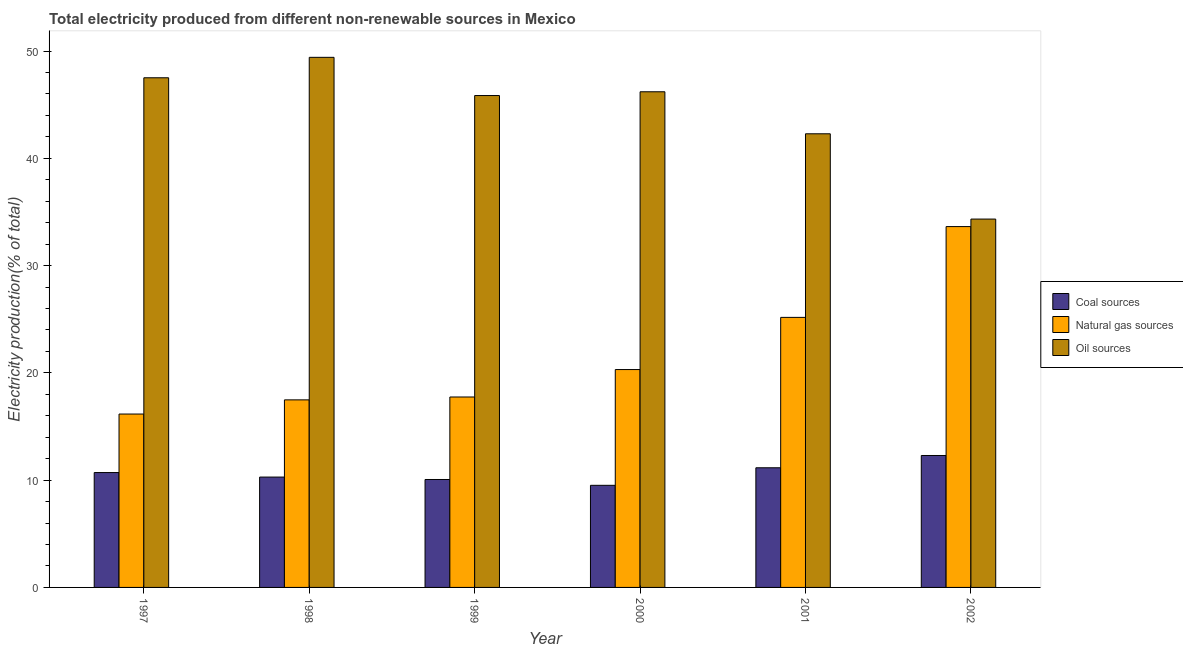Are the number of bars on each tick of the X-axis equal?
Your response must be concise. Yes. How many bars are there on the 6th tick from the left?
Provide a succinct answer. 3. How many bars are there on the 5th tick from the right?
Ensure brevity in your answer.  3. What is the label of the 5th group of bars from the left?
Ensure brevity in your answer.  2001. What is the percentage of electricity produced by oil sources in 2001?
Your answer should be very brief. 42.28. Across all years, what is the maximum percentage of electricity produced by oil sources?
Offer a very short reply. 49.41. Across all years, what is the minimum percentage of electricity produced by coal?
Keep it short and to the point. 9.52. In which year was the percentage of electricity produced by natural gas maximum?
Provide a succinct answer. 2002. In which year was the percentage of electricity produced by coal minimum?
Provide a succinct answer. 2000. What is the total percentage of electricity produced by natural gas in the graph?
Your response must be concise. 130.51. What is the difference between the percentage of electricity produced by natural gas in 1997 and that in 2000?
Your response must be concise. -4.15. What is the difference between the percentage of electricity produced by oil sources in 2000 and the percentage of electricity produced by coal in 2002?
Make the answer very short. 11.87. What is the average percentage of electricity produced by oil sources per year?
Your response must be concise. 44.26. What is the ratio of the percentage of electricity produced by natural gas in 1997 to that in 2001?
Your answer should be very brief. 0.64. Is the percentage of electricity produced by natural gas in 1997 less than that in 2001?
Offer a very short reply. Yes. What is the difference between the highest and the second highest percentage of electricity produced by oil sources?
Your response must be concise. 1.91. What is the difference between the highest and the lowest percentage of electricity produced by oil sources?
Your response must be concise. 15.08. Is the sum of the percentage of electricity produced by oil sources in 2000 and 2001 greater than the maximum percentage of electricity produced by natural gas across all years?
Keep it short and to the point. Yes. What does the 2nd bar from the left in 2002 represents?
Your answer should be very brief. Natural gas sources. What does the 1st bar from the right in 1998 represents?
Make the answer very short. Oil sources. Are all the bars in the graph horizontal?
Provide a succinct answer. No. How many years are there in the graph?
Provide a short and direct response. 6. Does the graph contain any zero values?
Make the answer very short. No. Where does the legend appear in the graph?
Ensure brevity in your answer.  Center right. How many legend labels are there?
Your response must be concise. 3. What is the title of the graph?
Make the answer very short. Total electricity produced from different non-renewable sources in Mexico. What is the label or title of the Y-axis?
Provide a short and direct response. Electricity production(% of total). What is the Electricity production(% of total) in Coal sources in 1997?
Offer a very short reply. 10.71. What is the Electricity production(% of total) in Natural gas sources in 1997?
Ensure brevity in your answer.  16.16. What is the Electricity production(% of total) of Oil sources in 1997?
Your answer should be compact. 47.5. What is the Electricity production(% of total) in Coal sources in 1998?
Offer a terse response. 10.29. What is the Electricity production(% of total) in Natural gas sources in 1998?
Give a very brief answer. 17.48. What is the Electricity production(% of total) in Oil sources in 1998?
Your answer should be compact. 49.41. What is the Electricity production(% of total) of Coal sources in 1999?
Keep it short and to the point. 10.06. What is the Electricity production(% of total) of Natural gas sources in 1999?
Keep it short and to the point. 17.75. What is the Electricity production(% of total) of Oil sources in 1999?
Your answer should be very brief. 45.85. What is the Electricity production(% of total) of Coal sources in 2000?
Provide a succinct answer. 9.52. What is the Electricity production(% of total) in Natural gas sources in 2000?
Give a very brief answer. 20.31. What is the Electricity production(% of total) of Oil sources in 2000?
Keep it short and to the point. 46.2. What is the Electricity production(% of total) in Coal sources in 2001?
Your answer should be compact. 11.15. What is the Electricity production(% of total) in Natural gas sources in 2001?
Your answer should be compact. 25.17. What is the Electricity production(% of total) of Oil sources in 2001?
Make the answer very short. 42.28. What is the Electricity production(% of total) in Coal sources in 2002?
Ensure brevity in your answer.  12.3. What is the Electricity production(% of total) in Natural gas sources in 2002?
Make the answer very short. 33.63. What is the Electricity production(% of total) of Oil sources in 2002?
Offer a very short reply. 34.33. Across all years, what is the maximum Electricity production(% of total) of Coal sources?
Offer a very short reply. 12.3. Across all years, what is the maximum Electricity production(% of total) in Natural gas sources?
Your answer should be very brief. 33.63. Across all years, what is the maximum Electricity production(% of total) of Oil sources?
Your answer should be very brief. 49.41. Across all years, what is the minimum Electricity production(% of total) in Coal sources?
Give a very brief answer. 9.52. Across all years, what is the minimum Electricity production(% of total) of Natural gas sources?
Provide a succinct answer. 16.16. Across all years, what is the minimum Electricity production(% of total) of Oil sources?
Provide a short and direct response. 34.33. What is the total Electricity production(% of total) of Coal sources in the graph?
Make the answer very short. 64.02. What is the total Electricity production(% of total) in Natural gas sources in the graph?
Provide a succinct answer. 130.51. What is the total Electricity production(% of total) of Oil sources in the graph?
Offer a very short reply. 265.58. What is the difference between the Electricity production(% of total) of Coal sources in 1997 and that in 1998?
Provide a short and direct response. 0.42. What is the difference between the Electricity production(% of total) of Natural gas sources in 1997 and that in 1998?
Your answer should be compact. -1.32. What is the difference between the Electricity production(% of total) in Oil sources in 1997 and that in 1998?
Your answer should be very brief. -1.91. What is the difference between the Electricity production(% of total) in Coal sources in 1997 and that in 1999?
Ensure brevity in your answer.  0.65. What is the difference between the Electricity production(% of total) of Natural gas sources in 1997 and that in 1999?
Ensure brevity in your answer.  -1.59. What is the difference between the Electricity production(% of total) of Oil sources in 1997 and that in 1999?
Offer a terse response. 1.66. What is the difference between the Electricity production(% of total) in Coal sources in 1997 and that in 2000?
Ensure brevity in your answer.  1.19. What is the difference between the Electricity production(% of total) of Natural gas sources in 1997 and that in 2000?
Ensure brevity in your answer.  -4.15. What is the difference between the Electricity production(% of total) of Oil sources in 1997 and that in 2000?
Your response must be concise. 1.31. What is the difference between the Electricity production(% of total) of Coal sources in 1997 and that in 2001?
Make the answer very short. -0.45. What is the difference between the Electricity production(% of total) of Natural gas sources in 1997 and that in 2001?
Your answer should be compact. -9.01. What is the difference between the Electricity production(% of total) of Oil sources in 1997 and that in 2001?
Provide a short and direct response. 5.22. What is the difference between the Electricity production(% of total) in Coal sources in 1997 and that in 2002?
Offer a terse response. -1.59. What is the difference between the Electricity production(% of total) in Natural gas sources in 1997 and that in 2002?
Provide a short and direct response. -17.47. What is the difference between the Electricity production(% of total) in Oil sources in 1997 and that in 2002?
Your answer should be very brief. 13.17. What is the difference between the Electricity production(% of total) of Coal sources in 1998 and that in 1999?
Offer a very short reply. 0.23. What is the difference between the Electricity production(% of total) of Natural gas sources in 1998 and that in 1999?
Make the answer very short. -0.27. What is the difference between the Electricity production(% of total) of Oil sources in 1998 and that in 1999?
Make the answer very short. 3.56. What is the difference between the Electricity production(% of total) of Coal sources in 1998 and that in 2000?
Ensure brevity in your answer.  0.77. What is the difference between the Electricity production(% of total) in Natural gas sources in 1998 and that in 2000?
Your answer should be compact. -2.83. What is the difference between the Electricity production(% of total) in Oil sources in 1998 and that in 2000?
Ensure brevity in your answer.  3.21. What is the difference between the Electricity production(% of total) in Coal sources in 1998 and that in 2001?
Your answer should be very brief. -0.87. What is the difference between the Electricity production(% of total) in Natural gas sources in 1998 and that in 2001?
Ensure brevity in your answer.  -7.69. What is the difference between the Electricity production(% of total) of Oil sources in 1998 and that in 2001?
Offer a terse response. 7.13. What is the difference between the Electricity production(% of total) of Coal sources in 1998 and that in 2002?
Your response must be concise. -2.01. What is the difference between the Electricity production(% of total) of Natural gas sources in 1998 and that in 2002?
Offer a very short reply. -16.15. What is the difference between the Electricity production(% of total) in Oil sources in 1998 and that in 2002?
Make the answer very short. 15.08. What is the difference between the Electricity production(% of total) in Coal sources in 1999 and that in 2000?
Your answer should be compact. 0.54. What is the difference between the Electricity production(% of total) of Natural gas sources in 1999 and that in 2000?
Provide a succinct answer. -2.56. What is the difference between the Electricity production(% of total) of Oil sources in 1999 and that in 2000?
Make the answer very short. -0.35. What is the difference between the Electricity production(% of total) in Coal sources in 1999 and that in 2001?
Provide a succinct answer. -1.09. What is the difference between the Electricity production(% of total) of Natural gas sources in 1999 and that in 2001?
Your response must be concise. -7.42. What is the difference between the Electricity production(% of total) of Oil sources in 1999 and that in 2001?
Provide a succinct answer. 3.57. What is the difference between the Electricity production(% of total) in Coal sources in 1999 and that in 2002?
Your response must be concise. -2.24. What is the difference between the Electricity production(% of total) of Natural gas sources in 1999 and that in 2002?
Offer a very short reply. -15.88. What is the difference between the Electricity production(% of total) in Oil sources in 1999 and that in 2002?
Your response must be concise. 11.51. What is the difference between the Electricity production(% of total) of Coal sources in 2000 and that in 2001?
Keep it short and to the point. -1.64. What is the difference between the Electricity production(% of total) of Natural gas sources in 2000 and that in 2001?
Ensure brevity in your answer.  -4.86. What is the difference between the Electricity production(% of total) of Oil sources in 2000 and that in 2001?
Give a very brief answer. 3.92. What is the difference between the Electricity production(% of total) of Coal sources in 2000 and that in 2002?
Make the answer very short. -2.78. What is the difference between the Electricity production(% of total) in Natural gas sources in 2000 and that in 2002?
Provide a short and direct response. -13.33. What is the difference between the Electricity production(% of total) of Oil sources in 2000 and that in 2002?
Your answer should be very brief. 11.87. What is the difference between the Electricity production(% of total) in Coal sources in 2001 and that in 2002?
Make the answer very short. -1.14. What is the difference between the Electricity production(% of total) of Natural gas sources in 2001 and that in 2002?
Your response must be concise. -8.46. What is the difference between the Electricity production(% of total) of Oil sources in 2001 and that in 2002?
Your response must be concise. 7.95. What is the difference between the Electricity production(% of total) of Coal sources in 1997 and the Electricity production(% of total) of Natural gas sources in 1998?
Your answer should be compact. -6.78. What is the difference between the Electricity production(% of total) in Coal sources in 1997 and the Electricity production(% of total) in Oil sources in 1998?
Give a very brief answer. -38.7. What is the difference between the Electricity production(% of total) in Natural gas sources in 1997 and the Electricity production(% of total) in Oil sources in 1998?
Offer a very short reply. -33.25. What is the difference between the Electricity production(% of total) in Coal sources in 1997 and the Electricity production(% of total) in Natural gas sources in 1999?
Keep it short and to the point. -7.04. What is the difference between the Electricity production(% of total) of Coal sources in 1997 and the Electricity production(% of total) of Oil sources in 1999?
Offer a terse response. -35.14. What is the difference between the Electricity production(% of total) of Natural gas sources in 1997 and the Electricity production(% of total) of Oil sources in 1999?
Provide a short and direct response. -29.69. What is the difference between the Electricity production(% of total) in Coal sources in 1997 and the Electricity production(% of total) in Natural gas sources in 2000?
Ensure brevity in your answer.  -9.6. What is the difference between the Electricity production(% of total) in Coal sources in 1997 and the Electricity production(% of total) in Oil sources in 2000?
Your response must be concise. -35.49. What is the difference between the Electricity production(% of total) in Natural gas sources in 1997 and the Electricity production(% of total) in Oil sources in 2000?
Your answer should be very brief. -30.04. What is the difference between the Electricity production(% of total) in Coal sources in 1997 and the Electricity production(% of total) in Natural gas sources in 2001?
Provide a short and direct response. -14.46. What is the difference between the Electricity production(% of total) in Coal sources in 1997 and the Electricity production(% of total) in Oil sources in 2001?
Give a very brief answer. -31.58. What is the difference between the Electricity production(% of total) in Natural gas sources in 1997 and the Electricity production(% of total) in Oil sources in 2001?
Offer a terse response. -26.12. What is the difference between the Electricity production(% of total) in Coal sources in 1997 and the Electricity production(% of total) in Natural gas sources in 2002?
Ensure brevity in your answer.  -22.93. What is the difference between the Electricity production(% of total) of Coal sources in 1997 and the Electricity production(% of total) of Oil sources in 2002?
Offer a terse response. -23.63. What is the difference between the Electricity production(% of total) of Natural gas sources in 1997 and the Electricity production(% of total) of Oil sources in 2002?
Your response must be concise. -18.17. What is the difference between the Electricity production(% of total) of Coal sources in 1998 and the Electricity production(% of total) of Natural gas sources in 1999?
Provide a short and direct response. -7.46. What is the difference between the Electricity production(% of total) of Coal sources in 1998 and the Electricity production(% of total) of Oil sources in 1999?
Keep it short and to the point. -35.56. What is the difference between the Electricity production(% of total) of Natural gas sources in 1998 and the Electricity production(% of total) of Oil sources in 1999?
Give a very brief answer. -28.37. What is the difference between the Electricity production(% of total) in Coal sources in 1998 and the Electricity production(% of total) in Natural gas sources in 2000?
Your response must be concise. -10.02. What is the difference between the Electricity production(% of total) in Coal sources in 1998 and the Electricity production(% of total) in Oil sources in 2000?
Ensure brevity in your answer.  -35.91. What is the difference between the Electricity production(% of total) in Natural gas sources in 1998 and the Electricity production(% of total) in Oil sources in 2000?
Provide a succinct answer. -28.72. What is the difference between the Electricity production(% of total) in Coal sources in 1998 and the Electricity production(% of total) in Natural gas sources in 2001?
Ensure brevity in your answer.  -14.88. What is the difference between the Electricity production(% of total) in Coal sources in 1998 and the Electricity production(% of total) in Oil sources in 2001?
Offer a very short reply. -32. What is the difference between the Electricity production(% of total) in Natural gas sources in 1998 and the Electricity production(% of total) in Oil sources in 2001?
Your answer should be compact. -24.8. What is the difference between the Electricity production(% of total) of Coal sources in 1998 and the Electricity production(% of total) of Natural gas sources in 2002?
Your answer should be very brief. -23.35. What is the difference between the Electricity production(% of total) of Coal sources in 1998 and the Electricity production(% of total) of Oil sources in 2002?
Ensure brevity in your answer.  -24.05. What is the difference between the Electricity production(% of total) in Natural gas sources in 1998 and the Electricity production(% of total) in Oil sources in 2002?
Offer a very short reply. -16.85. What is the difference between the Electricity production(% of total) of Coal sources in 1999 and the Electricity production(% of total) of Natural gas sources in 2000?
Your response must be concise. -10.25. What is the difference between the Electricity production(% of total) in Coal sources in 1999 and the Electricity production(% of total) in Oil sources in 2000?
Your response must be concise. -36.14. What is the difference between the Electricity production(% of total) in Natural gas sources in 1999 and the Electricity production(% of total) in Oil sources in 2000?
Give a very brief answer. -28.45. What is the difference between the Electricity production(% of total) of Coal sources in 1999 and the Electricity production(% of total) of Natural gas sources in 2001?
Provide a short and direct response. -15.11. What is the difference between the Electricity production(% of total) of Coal sources in 1999 and the Electricity production(% of total) of Oil sources in 2001?
Offer a very short reply. -32.22. What is the difference between the Electricity production(% of total) in Natural gas sources in 1999 and the Electricity production(% of total) in Oil sources in 2001?
Provide a succinct answer. -24.53. What is the difference between the Electricity production(% of total) in Coal sources in 1999 and the Electricity production(% of total) in Natural gas sources in 2002?
Your response must be concise. -23.57. What is the difference between the Electricity production(% of total) in Coal sources in 1999 and the Electricity production(% of total) in Oil sources in 2002?
Keep it short and to the point. -24.27. What is the difference between the Electricity production(% of total) in Natural gas sources in 1999 and the Electricity production(% of total) in Oil sources in 2002?
Your answer should be very brief. -16.58. What is the difference between the Electricity production(% of total) of Coal sources in 2000 and the Electricity production(% of total) of Natural gas sources in 2001?
Give a very brief answer. -15.65. What is the difference between the Electricity production(% of total) of Coal sources in 2000 and the Electricity production(% of total) of Oil sources in 2001?
Offer a terse response. -32.77. What is the difference between the Electricity production(% of total) of Natural gas sources in 2000 and the Electricity production(% of total) of Oil sources in 2001?
Give a very brief answer. -21.98. What is the difference between the Electricity production(% of total) in Coal sources in 2000 and the Electricity production(% of total) in Natural gas sources in 2002?
Your response must be concise. -24.12. What is the difference between the Electricity production(% of total) of Coal sources in 2000 and the Electricity production(% of total) of Oil sources in 2002?
Your response must be concise. -24.82. What is the difference between the Electricity production(% of total) in Natural gas sources in 2000 and the Electricity production(% of total) in Oil sources in 2002?
Provide a short and direct response. -14.03. What is the difference between the Electricity production(% of total) of Coal sources in 2001 and the Electricity production(% of total) of Natural gas sources in 2002?
Offer a very short reply. -22.48. What is the difference between the Electricity production(% of total) of Coal sources in 2001 and the Electricity production(% of total) of Oil sources in 2002?
Provide a short and direct response. -23.18. What is the difference between the Electricity production(% of total) of Natural gas sources in 2001 and the Electricity production(% of total) of Oil sources in 2002?
Offer a terse response. -9.16. What is the average Electricity production(% of total) in Coal sources per year?
Provide a short and direct response. 10.67. What is the average Electricity production(% of total) of Natural gas sources per year?
Provide a succinct answer. 21.75. What is the average Electricity production(% of total) in Oil sources per year?
Keep it short and to the point. 44.26. In the year 1997, what is the difference between the Electricity production(% of total) in Coal sources and Electricity production(% of total) in Natural gas sources?
Give a very brief answer. -5.45. In the year 1997, what is the difference between the Electricity production(% of total) of Coal sources and Electricity production(% of total) of Oil sources?
Your answer should be compact. -36.8. In the year 1997, what is the difference between the Electricity production(% of total) in Natural gas sources and Electricity production(% of total) in Oil sources?
Offer a very short reply. -31.34. In the year 1998, what is the difference between the Electricity production(% of total) in Coal sources and Electricity production(% of total) in Natural gas sources?
Provide a succinct answer. -7.19. In the year 1998, what is the difference between the Electricity production(% of total) of Coal sources and Electricity production(% of total) of Oil sources?
Keep it short and to the point. -39.12. In the year 1998, what is the difference between the Electricity production(% of total) of Natural gas sources and Electricity production(% of total) of Oil sources?
Give a very brief answer. -31.93. In the year 1999, what is the difference between the Electricity production(% of total) of Coal sources and Electricity production(% of total) of Natural gas sources?
Offer a very short reply. -7.69. In the year 1999, what is the difference between the Electricity production(% of total) in Coal sources and Electricity production(% of total) in Oil sources?
Provide a succinct answer. -35.79. In the year 1999, what is the difference between the Electricity production(% of total) of Natural gas sources and Electricity production(% of total) of Oil sources?
Your answer should be compact. -28.1. In the year 2000, what is the difference between the Electricity production(% of total) in Coal sources and Electricity production(% of total) in Natural gas sources?
Offer a very short reply. -10.79. In the year 2000, what is the difference between the Electricity production(% of total) of Coal sources and Electricity production(% of total) of Oil sources?
Your answer should be very brief. -36.68. In the year 2000, what is the difference between the Electricity production(% of total) in Natural gas sources and Electricity production(% of total) in Oil sources?
Keep it short and to the point. -25.89. In the year 2001, what is the difference between the Electricity production(% of total) in Coal sources and Electricity production(% of total) in Natural gas sources?
Provide a short and direct response. -14.02. In the year 2001, what is the difference between the Electricity production(% of total) in Coal sources and Electricity production(% of total) in Oil sources?
Keep it short and to the point. -31.13. In the year 2001, what is the difference between the Electricity production(% of total) of Natural gas sources and Electricity production(% of total) of Oil sources?
Keep it short and to the point. -17.11. In the year 2002, what is the difference between the Electricity production(% of total) in Coal sources and Electricity production(% of total) in Natural gas sources?
Give a very brief answer. -21.34. In the year 2002, what is the difference between the Electricity production(% of total) of Coal sources and Electricity production(% of total) of Oil sources?
Ensure brevity in your answer.  -22.04. In the year 2002, what is the difference between the Electricity production(% of total) of Natural gas sources and Electricity production(% of total) of Oil sources?
Provide a short and direct response. -0.7. What is the ratio of the Electricity production(% of total) of Coal sources in 1997 to that in 1998?
Your answer should be compact. 1.04. What is the ratio of the Electricity production(% of total) of Natural gas sources in 1997 to that in 1998?
Your response must be concise. 0.92. What is the ratio of the Electricity production(% of total) in Oil sources in 1997 to that in 1998?
Provide a succinct answer. 0.96. What is the ratio of the Electricity production(% of total) of Coal sources in 1997 to that in 1999?
Keep it short and to the point. 1.06. What is the ratio of the Electricity production(% of total) in Natural gas sources in 1997 to that in 1999?
Provide a short and direct response. 0.91. What is the ratio of the Electricity production(% of total) in Oil sources in 1997 to that in 1999?
Ensure brevity in your answer.  1.04. What is the ratio of the Electricity production(% of total) in Coal sources in 1997 to that in 2000?
Offer a very short reply. 1.12. What is the ratio of the Electricity production(% of total) in Natural gas sources in 1997 to that in 2000?
Offer a terse response. 0.8. What is the ratio of the Electricity production(% of total) of Oil sources in 1997 to that in 2000?
Make the answer very short. 1.03. What is the ratio of the Electricity production(% of total) of Coal sources in 1997 to that in 2001?
Provide a succinct answer. 0.96. What is the ratio of the Electricity production(% of total) in Natural gas sources in 1997 to that in 2001?
Make the answer very short. 0.64. What is the ratio of the Electricity production(% of total) of Oil sources in 1997 to that in 2001?
Your answer should be compact. 1.12. What is the ratio of the Electricity production(% of total) in Coal sources in 1997 to that in 2002?
Give a very brief answer. 0.87. What is the ratio of the Electricity production(% of total) in Natural gas sources in 1997 to that in 2002?
Keep it short and to the point. 0.48. What is the ratio of the Electricity production(% of total) of Oil sources in 1997 to that in 2002?
Make the answer very short. 1.38. What is the ratio of the Electricity production(% of total) of Coal sources in 1998 to that in 1999?
Keep it short and to the point. 1.02. What is the ratio of the Electricity production(% of total) in Natural gas sources in 1998 to that in 1999?
Your answer should be compact. 0.98. What is the ratio of the Electricity production(% of total) of Oil sources in 1998 to that in 1999?
Offer a terse response. 1.08. What is the ratio of the Electricity production(% of total) in Coal sources in 1998 to that in 2000?
Keep it short and to the point. 1.08. What is the ratio of the Electricity production(% of total) in Natural gas sources in 1998 to that in 2000?
Your answer should be compact. 0.86. What is the ratio of the Electricity production(% of total) of Oil sources in 1998 to that in 2000?
Offer a very short reply. 1.07. What is the ratio of the Electricity production(% of total) of Coal sources in 1998 to that in 2001?
Your answer should be compact. 0.92. What is the ratio of the Electricity production(% of total) of Natural gas sources in 1998 to that in 2001?
Offer a terse response. 0.69. What is the ratio of the Electricity production(% of total) in Oil sources in 1998 to that in 2001?
Offer a terse response. 1.17. What is the ratio of the Electricity production(% of total) in Coal sources in 1998 to that in 2002?
Offer a terse response. 0.84. What is the ratio of the Electricity production(% of total) in Natural gas sources in 1998 to that in 2002?
Keep it short and to the point. 0.52. What is the ratio of the Electricity production(% of total) in Oil sources in 1998 to that in 2002?
Keep it short and to the point. 1.44. What is the ratio of the Electricity production(% of total) of Coal sources in 1999 to that in 2000?
Ensure brevity in your answer.  1.06. What is the ratio of the Electricity production(% of total) in Natural gas sources in 1999 to that in 2000?
Your answer should be compact. 0.87. What is the ratio of the Electricity production(% of total) in Oil sources in 1999 to that in 2000?
Provide a succinct answer. 0.99. What is the ratio of the Electricity production(% of total) of Coal sources in 1999 to that in 2001?
Give a very brief answer. 0.9. What is the ratio of the Electricity production(% of total) of Natural gas sources in 1999 to that in 2001?
Offer a terse response. 0.71. What is the ratio of the Electricity production(% of total) of Oil sources in 1999 to that in 2001?
Provide a succinct answer. 1.08. What is the ratio of the Electricity production(% of total) in Coal sources in 1999 to that in 2002?
Your answer should be compact. 0.82. What is the ratio of the Electricity production(% of total) of Natural gas sources in 1999 to that in 2002?
Provide a succinct answer. 0.53. What is the ratio of the Electricity production(% of total) of Oil sources in 1999 to that in 2002?
Your response must be concise. 1.34. What is the ratio of the Electricity production(% of total) in Coal sources in 2000 to that in 2001?
Make the answer very short. 0.85. What is the ratio of the Electricity production(% of total) of Natural gas sources in 2000 to that in 2001?
Keep it short and to the point. 0.81. What is the ratio of the Electricity production(% of total) of Oil sources in 2000 to that in 2001?
Ensure brevity in your answer.  1.09. What is the ratio of the Electricity production(% of total) of Coal sources in 2000 to that in 2002?
Provide a succinct answer. 0.77. What is the ratio of the Electricity production(% of total) of Natural gas sources in 2000 to that in 2002?
Ensure brevity in your answer.  0.6. What is the ratio of the Electricity production(% of total) in Oil sources in 2000 to that in 2002?
Provide a succinct answer. 1.35. What is the ratio of the Electricity production(% of total) of Coal sources in 2001 to that in 2002?
Ensure brevity in your answer.  0.91. What is the ratio of the Electricity production(% of total) in Natural gas sources in 2001 to that in 2002?
Offer a terse response. 0.75. What is the ratio of the Electricity production(% of total) of Oil sources in 2001 to that in 2002?
Your response must be concise. 1.23. What is the difference between the highest and the second highest Electricity production(% of total) of Coal sources?
Make the answer very short. 1.14. What is the difference between the highest and the second highest Electricity production(% of total) in Natural gas sources?
Give a very brief answer. 8.46. What is the difference between the highest and the second highest Electricity production(% of total) in Oil sources?
Offer a terse response. 1.91. What is the difference between the highest and the lowest Electricity production(% of total) of Coal sources?
Give a very brief answer. 2.78. What is the difference between the highest and the lowest Electricity production(% of total) in Natural gas sources?
Offer a terse response. 17.47. What is the difference between the highest and the lowest Electricity production(% of total) in Oil sources?
Provide a succinct answer. 15.08. 